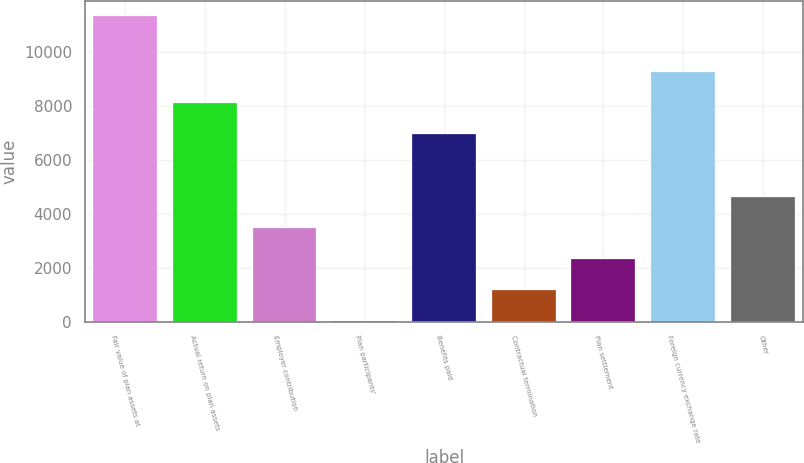Convert chart to OTSL. <chart><loc_0><loc_0><loc_500><loc_500><bar_chart><fcel>Fair value of plan assets at<fcel>Actual return on plan assets<fcel>Employer contribution<fcel>Plan participants'<fcel>Benefits paid<fcel>Contractual termination<fcel>Plan settlement<fcel>Foreign currency exchange rate<fcel>Other<nl><fcel>11343<fcel>8105.7<fcel>3481.3<fcel>13<fcel>6949.6<fcel>1169.1<fcel>2325.2<fcel>9261.8<fcel>4637.4<nl></chart> 